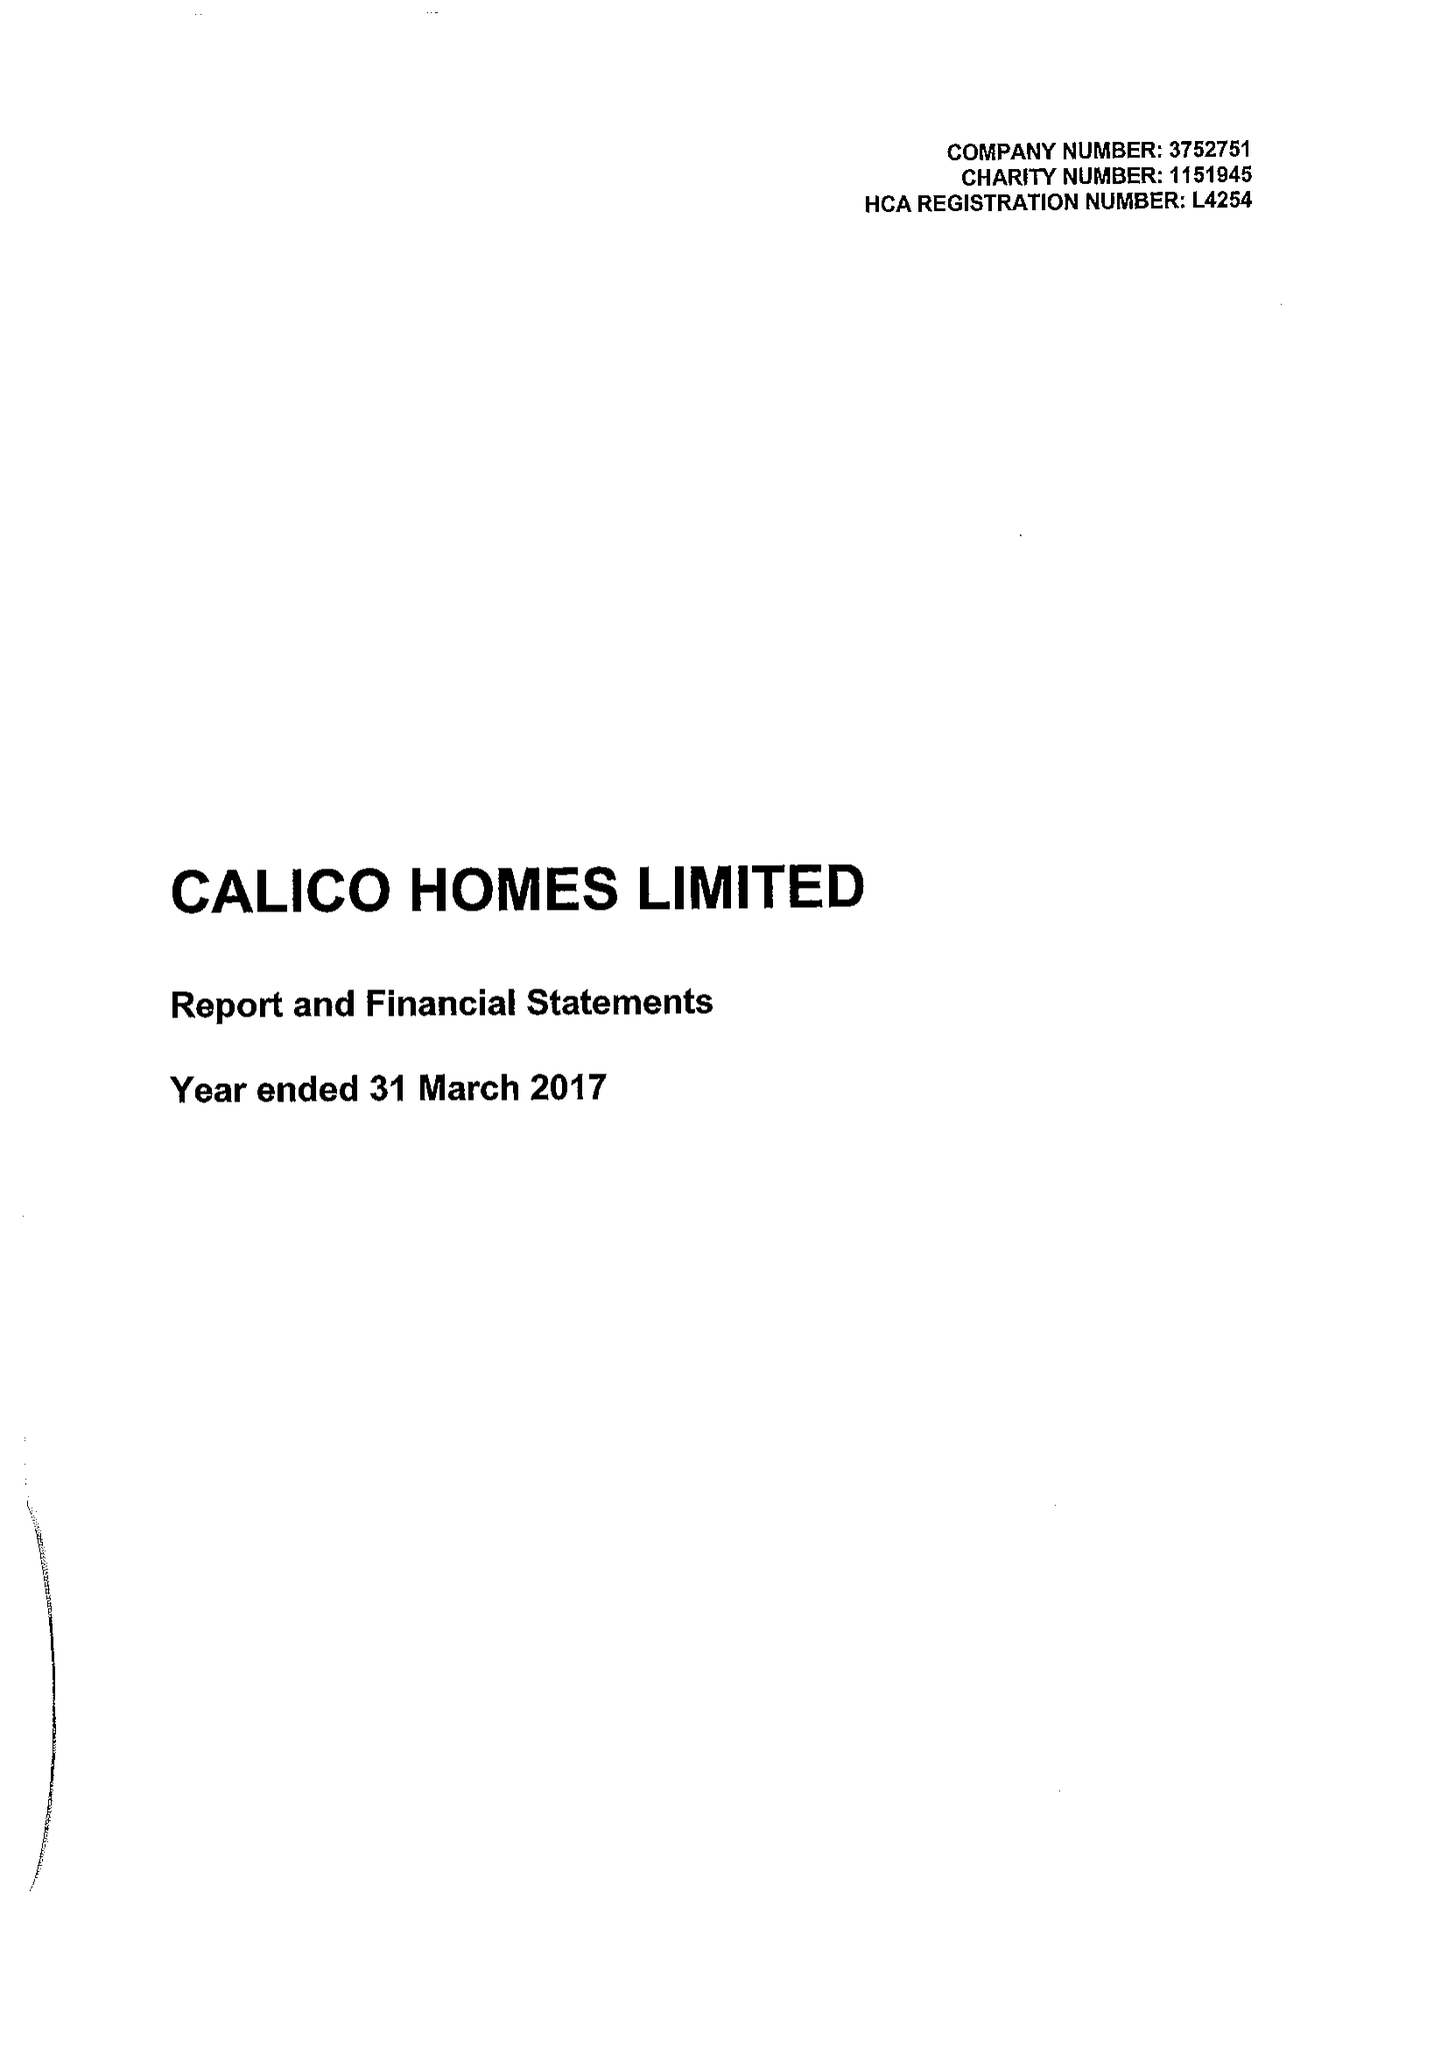What is the value for the address__postcode?
Answer the question using a single word or phrase. BB11 2ED 